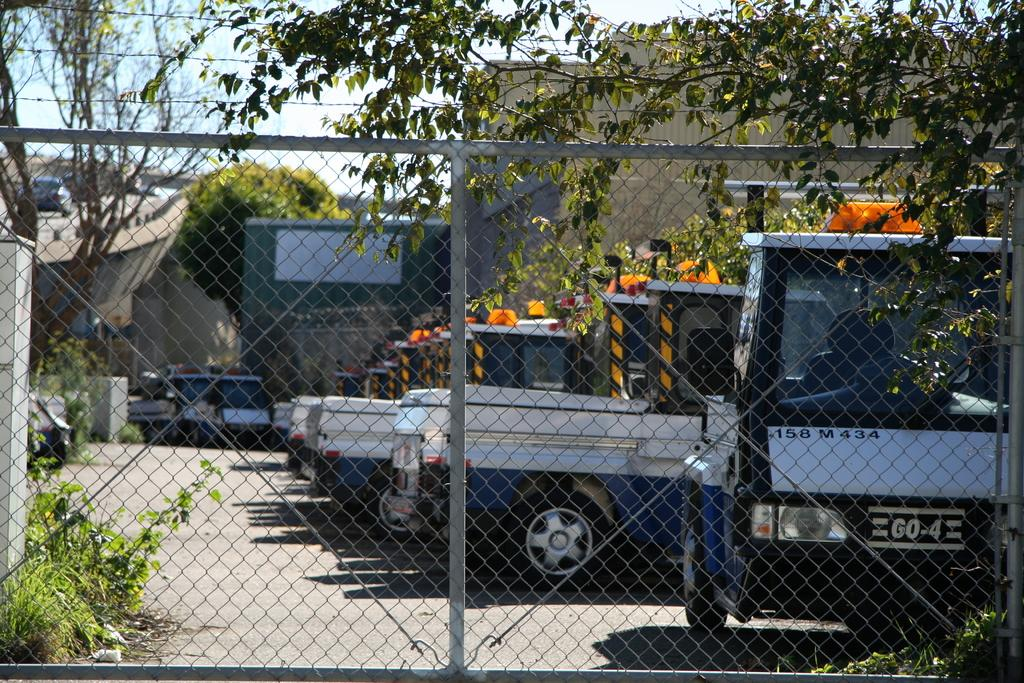What can be seen in the image that is used for transportation? There are vehicles parked in the image. What is separating the vehicles from the rest of the area? The vehicles are behind a metal grill. What type of natural elements can be seen in the image? There are trees visible in the image. What type of man-made structures can be seen in the image? There are buildings in the image. How many chairs are placed under the trees in the image? There are no chairs visible in the image; it only shows vehicles behind a metal grill, trees, and buildings. 